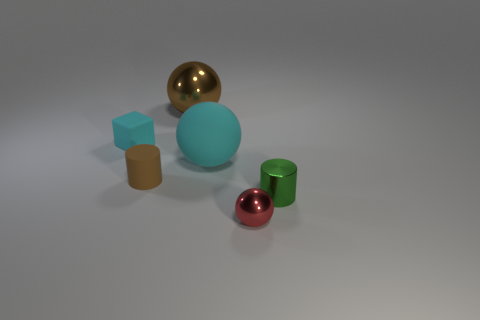What is the size of the cube that is the same color as the big rubber sphere?
Keep it short and to the point. Small. There is a metal sphere that is to the left of the red metal ball; does it have the same color as the matte cylinder?
Your response must be concise. Yes. There is another cyan thing that is the same shape as the big shiny thing; what is its size?
Offer a very short reply. Large. What material is the brown cylinder to the left of the metallic sphere behind the cylinder that is on the right side of the red metal thing?
Offer a terse response. Rubber. Is the number of cyan matte things that are on the right side of the brown sphere greater than the number of brown matte cylinders behind the tiny matte cylinder?
Your answer should be very brief. Yes. Do the red shiny object and the brown cylinder have the same size?
Offer a terse response. Yes. What is the color of the other big matte thing that is the same shape as the red thing?
Your response must be concise. Cyan. What number of small objects are the same color as the small metallic sphere?
Offer a very short reply. 0. Is the number of tiny cylinders to the right of the brown metal sphere greater than the number of tiny cyan rubber cylinders?
Keep it short and to the point. Yes. There is a shiny ball that is in front of the object to the left of the small brown rubber cylinder; what is its color?
Offer a terse response. Red. 